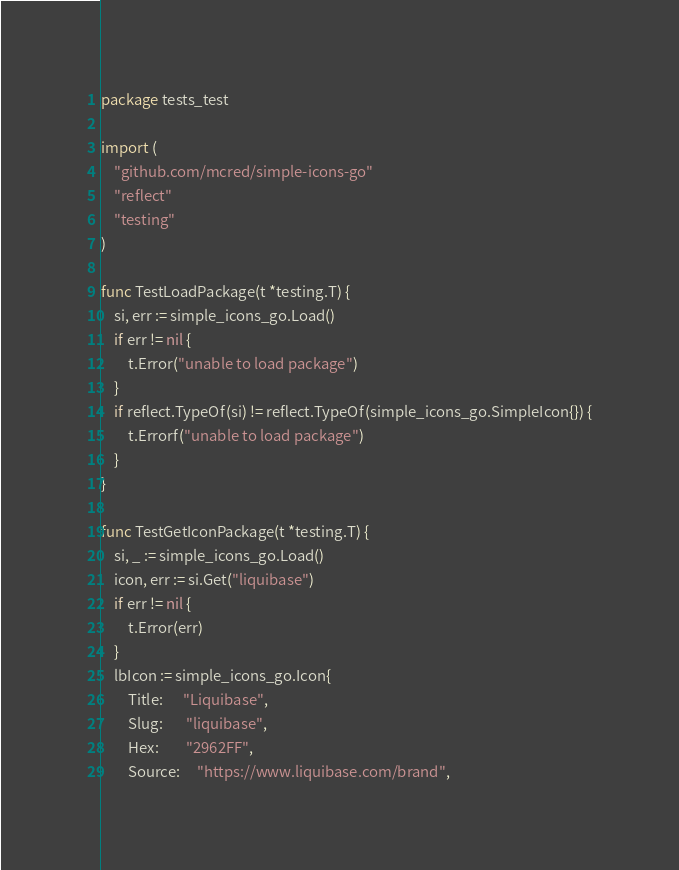Convert code to text. <code><loc_0><loc_0><loc_500><loc_500><_Go_>package tests_test

import (
	"github.com/mcred/simple-icons-go"
	"reflect"
	"testing"
)

func TestLoadPackage(t *testing.T) {
	si, err := simple_icons_go.Load()
	if err != nil {
		t.Error("unable to load package")
	}
	if reflect.TypeOf(si) != reflect.TypeOf(simple_icons_go.SimpleIcon{}) {
		t.Errorf("unable to load package")
	}
}

func TestGetIconPackage(t *testing.T) {
	si, _ := simple_icons_go.Load()
	icon, err := si.Get("liquibase")
	if err != nil {
		t.Error(err)
	}
	lbIcon := simple_icons_go.Icon{
		Title:      "Liquibase",
		Slug:       "liquibase",
		Hex:        "2962FF",
		Source:     "https://www.liquibase.com/brand",</code> 